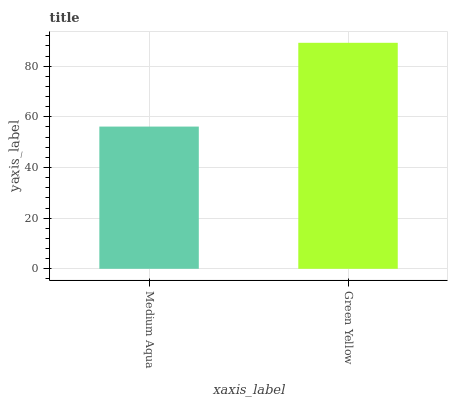Is Medium Aqua the minimum?
Answer yes or no. Yes. Is Green Yellow the maximum?
Answer yes or no. Yes. Is Green Yellow the minimum?
Answer yes or no. No. Is Green Yellow greater than Medium Aqua?
Answer yes or no. Yes. Is Medium Aqua less than Green Yellow?
Answer yes or no. Yes. Is Medium Aqua greater than Green Yellow?
Answer yes or no. No. Is Green Yellow less than Medium Aqua?
Answer yes or no. No. Is Green Yellow the high median?
Answer yes or no. Yes. Is Medium Aqua the low median?
Answer yes or no. Yes. Is Medium Aqua the high median?
Answer yes or no. No. Is Green Yellow the low median?
Answer yes or no. No. 